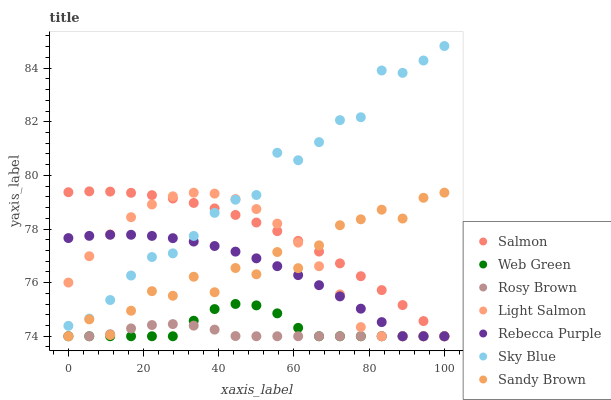Does Rosy Brown have the minimum area under the curve?
Answer yes or no. Yes. Does Sky Blue have the maximum area under the curve?
Answer yes or no. Yes. Does Salmon have the minimum area under the curve?
Answer yes or no. No. Does Salmon have the maximum area under the curve?
Answer yes or no. No. Is Salmon the smoothest?
Answer yes or no. Yes. Is Sandy Brown the roughest?
Answer yes or no. Yes. Is Rosy Brown the smoothest?
Answer yes or no. No. Is Rosy Brown the roughest?
Answer yes or no. No. Does Light Salmon have the lowest value?
Answer yes or no. Yes. Does Sky Blue have the lowest value?
Answer yes or no. No. Does Sky Blue have the highest value?
Answer yes or no. Yes. Does Salmon have the highest value?
Answer yes or no. No. Is Rosy Brown less than Sky Blue?
Answer yes or no. Yes. Is Sky Blue greater than Rosy Brown?
Answer yes or no. Yes. Does Sky Blue intersect Rebecca Purple?
Answer yes or no. Yes. Is Sky Blue less than Rebecca Purple?
Answer yes or no. No. Is Sky Blue greater than Rebecca Purple?
Answer yes or no. No. Does Rosy Brown intersect Sky Blue?
Answer yes or no. No. 